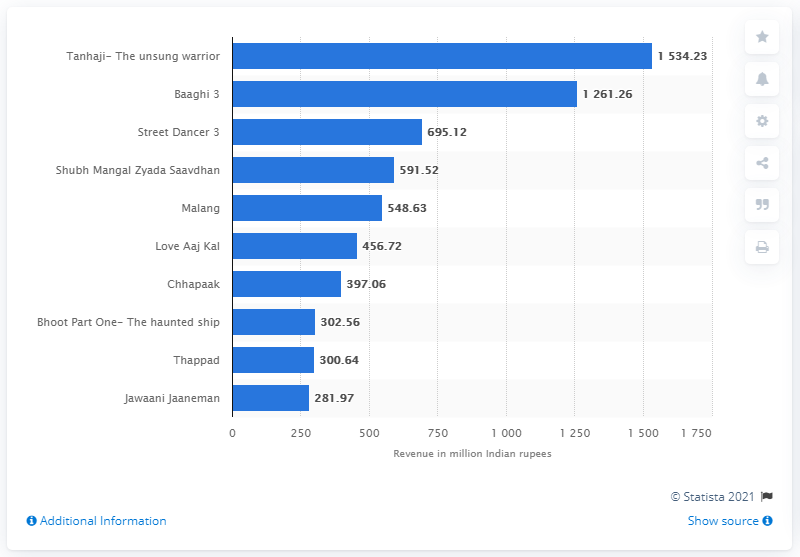Give some essential details in this illustration. Baaghi 3 and Street Dancer 3 were the second and third highest weekly grossers of the year, respectively, after the first-place finisher. 